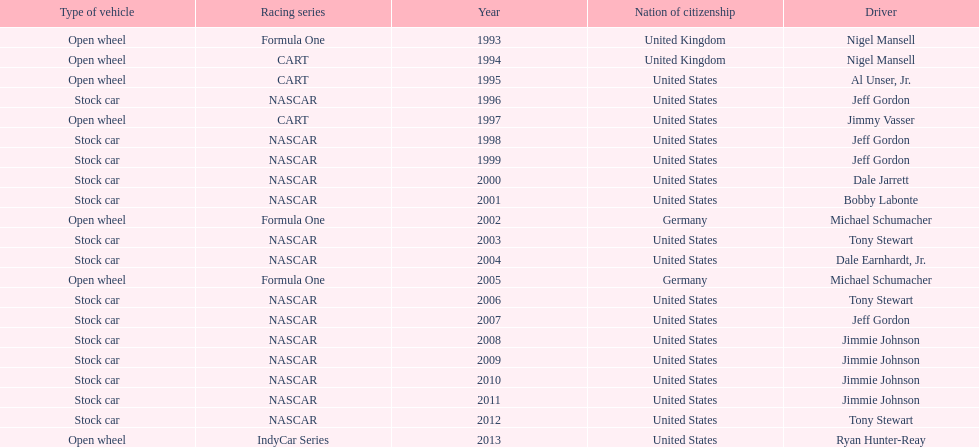Could you parse the entire table? {'header': ['Type of vehicle', 'Racing series', 'Year', 'Nation of citizenship', 'Driver'], 'rows': [['Open wheel', 'Formula One', '1993', 'United Kingdom', 'Nigel Mansell'], ['Open wheel', 'CART', '1994', 'United Kingdom', 'Nigel Mansell'], ['Open wheel', 'CART', '1995', 'United States', 'Al Unser, Jr.'], ['Stock car', 'NASCAR', '1996', 'United States', 'Jeff Gordon'], ['Open wheel', 'CART', '1997', 'United States', 'Jimmy Vasser'], ['Stock car', 'NASCAR', '1998', 'United States', 'Jeff Gordon'], ['Stock car', 'NASCAR', '1999', 'United States', 'Jeff Gordon'], ['Stock car', 'NASCAR', '2000', 'United States', 'Dale Jarrett'], ['Stock car', 'NASCAR', '2001', 'United States', 'Bobby Labonte'], ['Open wheel', 'Formula One', '2002', 'Germany', 'Michael Schumacher'], ['Stock car', 'NASCAR', '2003', 'United States', 'Tony Stewart'], ['Stock car', 'NASCAR', '2004', 'United States', 'Dale Earnhardt, Jr.'], ['Open wheel', 'Formula One', '2005', 'Germany', 'Michael Schumacher'], ['Stock car', 'NASCAR', '2006', 'United States', 'Tony Stewart'], ['Stock car', 'NASCAR', '2007', 'United States', 'Jeff Gordon'], ['Stock car', 'NASCAR', '2008', 'United States', 'Jimmie Johnson'], ['Stock car', 'NASCAR', '2009', 'United States', 'Jimmie Johnson'], ['Stock car', 'NASCAR', '2010', 'United States', 'Jimmie Johnson'], ['Stock car', 'NASCAR', '2011', 'United States', 'Jimmie Johnson'], ['Stock car', 'NASCAR', '2012', 'United States', 'Tony Stewart'], ['Open wheel', 'IndyCar Series', '2013', 'United States', 'Ryan Hunter-Reay']]} Besides nascar, what other racing series have espy-winning drivers come from? Formula One, CART, IndyCar Series. 